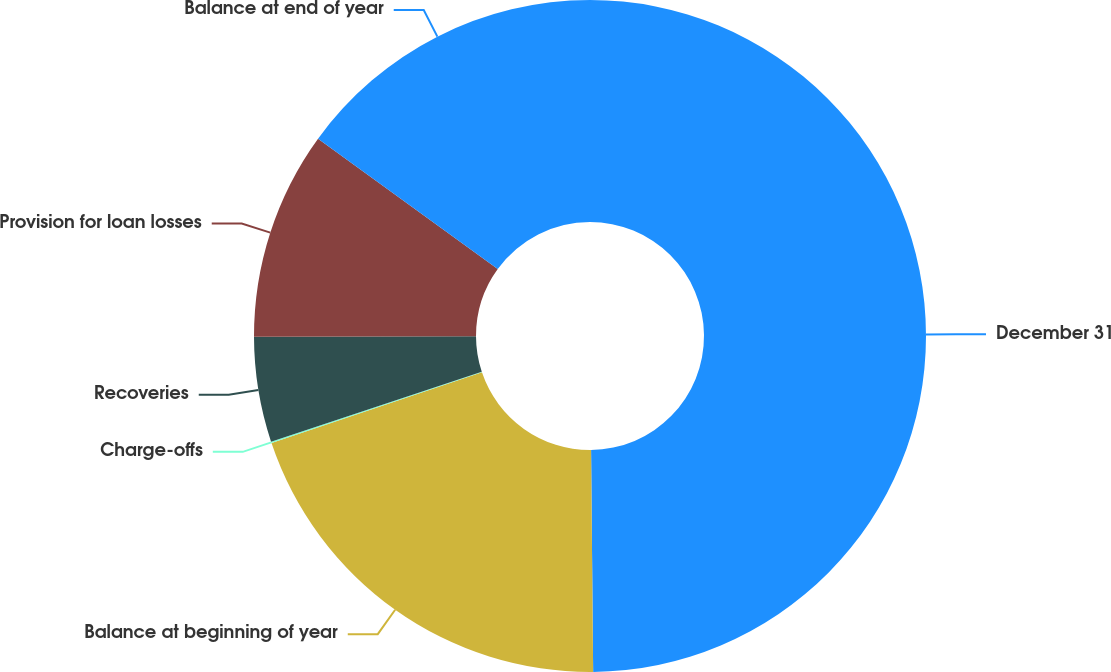<chart> <loc_0><loc_0><loc_500><loc_500><pie_chart><fcel>December 31<fcel>Balance at beginning of year<fcel>Charge-offs<fcel>Recoveries<fcel>Provision for loan losses<fcel>Balance at end of year<nl><fcel>49.85%<fcel>19.99%<fcel>0.07%<fcel>5.05%<fcel>10.03%<fcel>15.01%<nl></chart> 